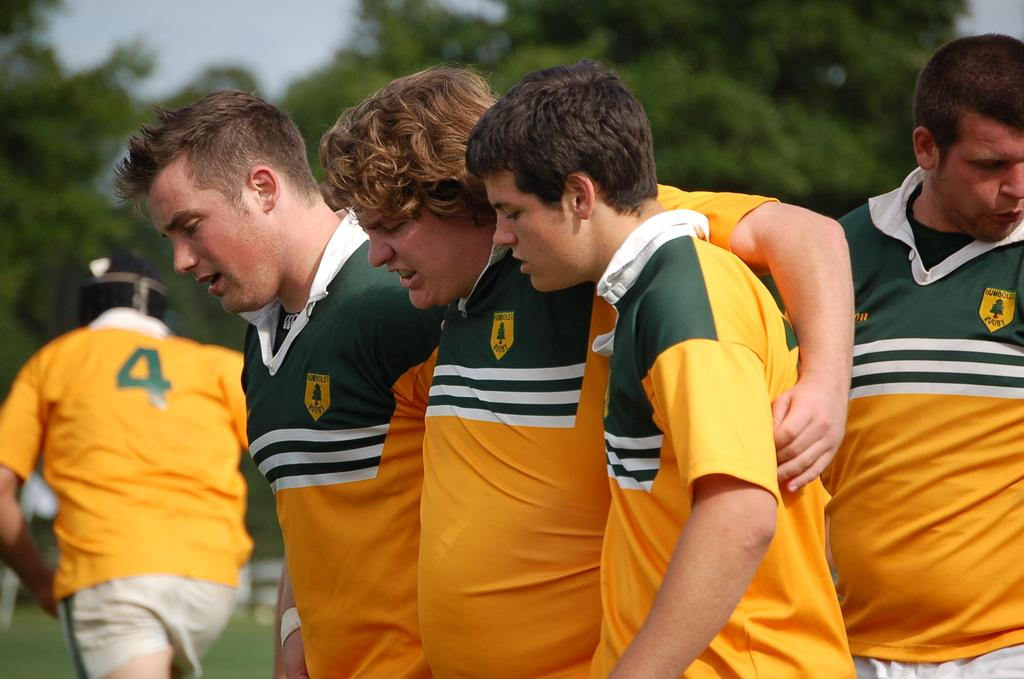<image>
Offer a succinct explanation of the picture presented. Several team players in yellow and green jersey stand around while the gentleman wearing number 4 walks away. 